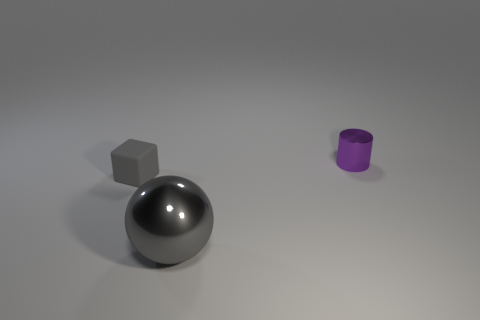Add 2 tiny brown metal cylinders. How many objects exist? 5 Subtract all cylinders. How many objects are left? 2 Subtract all blue shiny spheres. Subtract all small things. How many objects are left? 1 Add 2 big gray objects. How many big gray objects are left? 3 Add 3 tiny cubes. How many tiny cubes exist? 4 Subtract 1 gray balls. How many objects are left? 2 